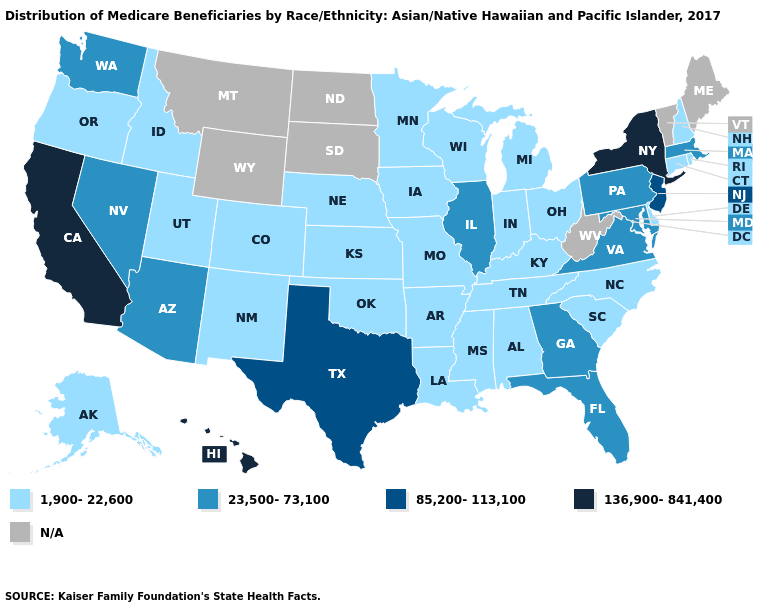Name the states that have a value in the range 23,500-73,100?
Keep it brief. Arizona, Florida, Georgia, Illinois, Maryland, Massachusetts, Nevada, Pennsylvania, Virginia, Washington. Name the states that have a value in the range N/A?
Be succinct. Maine, Montana, North Dakota, South Dakota, Vermont, West Virginia, Wyoming. Among the states that border Nevada , which have the highest value?
Give a very brief answer. California. What is the value of Florida?
Write a very short answer. 23,500-73,100. Does Wisconsin have the lowest value in the USA?
Give a very brief answer. Yes. What is the value of Ohio?
Keep it brief. 1,900-22,600. What is the value of New Hampshire?
Concise answer only. 1,900-22,600. What is the value of New York?
Short answer required. 136,900-841,400. Name the states that have a value in the range 85,200-113,100?
Short answer required. New Jersey, Texas. What is the value of Iowa?
Be succinct. 1,900-22,600. Among the states that border Tennessee , does Kentucky have the lowest value?
Quick response, please. Yes. Name the states that have a value in the range 136,900-841,400?
Concise answer only. California, Hawaii, New York. What is the value of Iowa?
Short answer required. 1,900-22,600. Which states hav the highest value in the MidWest?
Concise answer only. Illinois. 